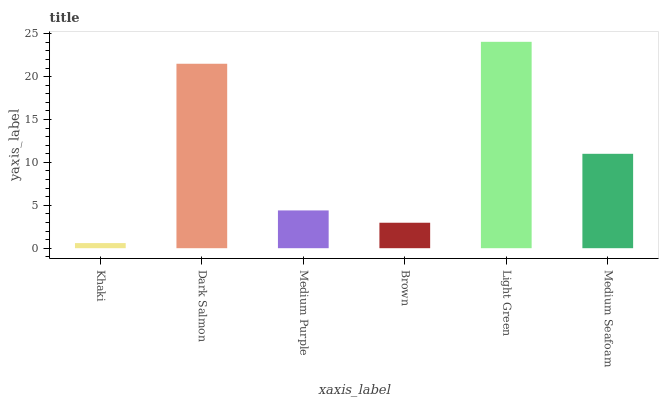Is Khaki the minimum?
Answer yes or no. Yes. Is Light Green the maximum?
Answer yes or no. Yes. Is Dark Salmon the minimum?
Answer yes or no. No. Is Dark Salmon the maximum?
Answer yes or no. No. Is Dark Salmon greater than Khaki?
Answer yes or no. Yes. Is Khaki less than Dark Salmon?
Answer yes or no. Yes. Is Khaki greater than Dark Salmon?
Answer yes or no. No. Is Dark Salmon less than Khaki?
Answer yes or no. No. Is Medium Seafoam the high median?
Answer yes or no. Yes. Is Medium Purple the low median?
Answer yes or no. Yes. Is Dark Salmon the high median?
Answer yes or no. No. Is Light Green the low median?
Answer yes or no. No. 